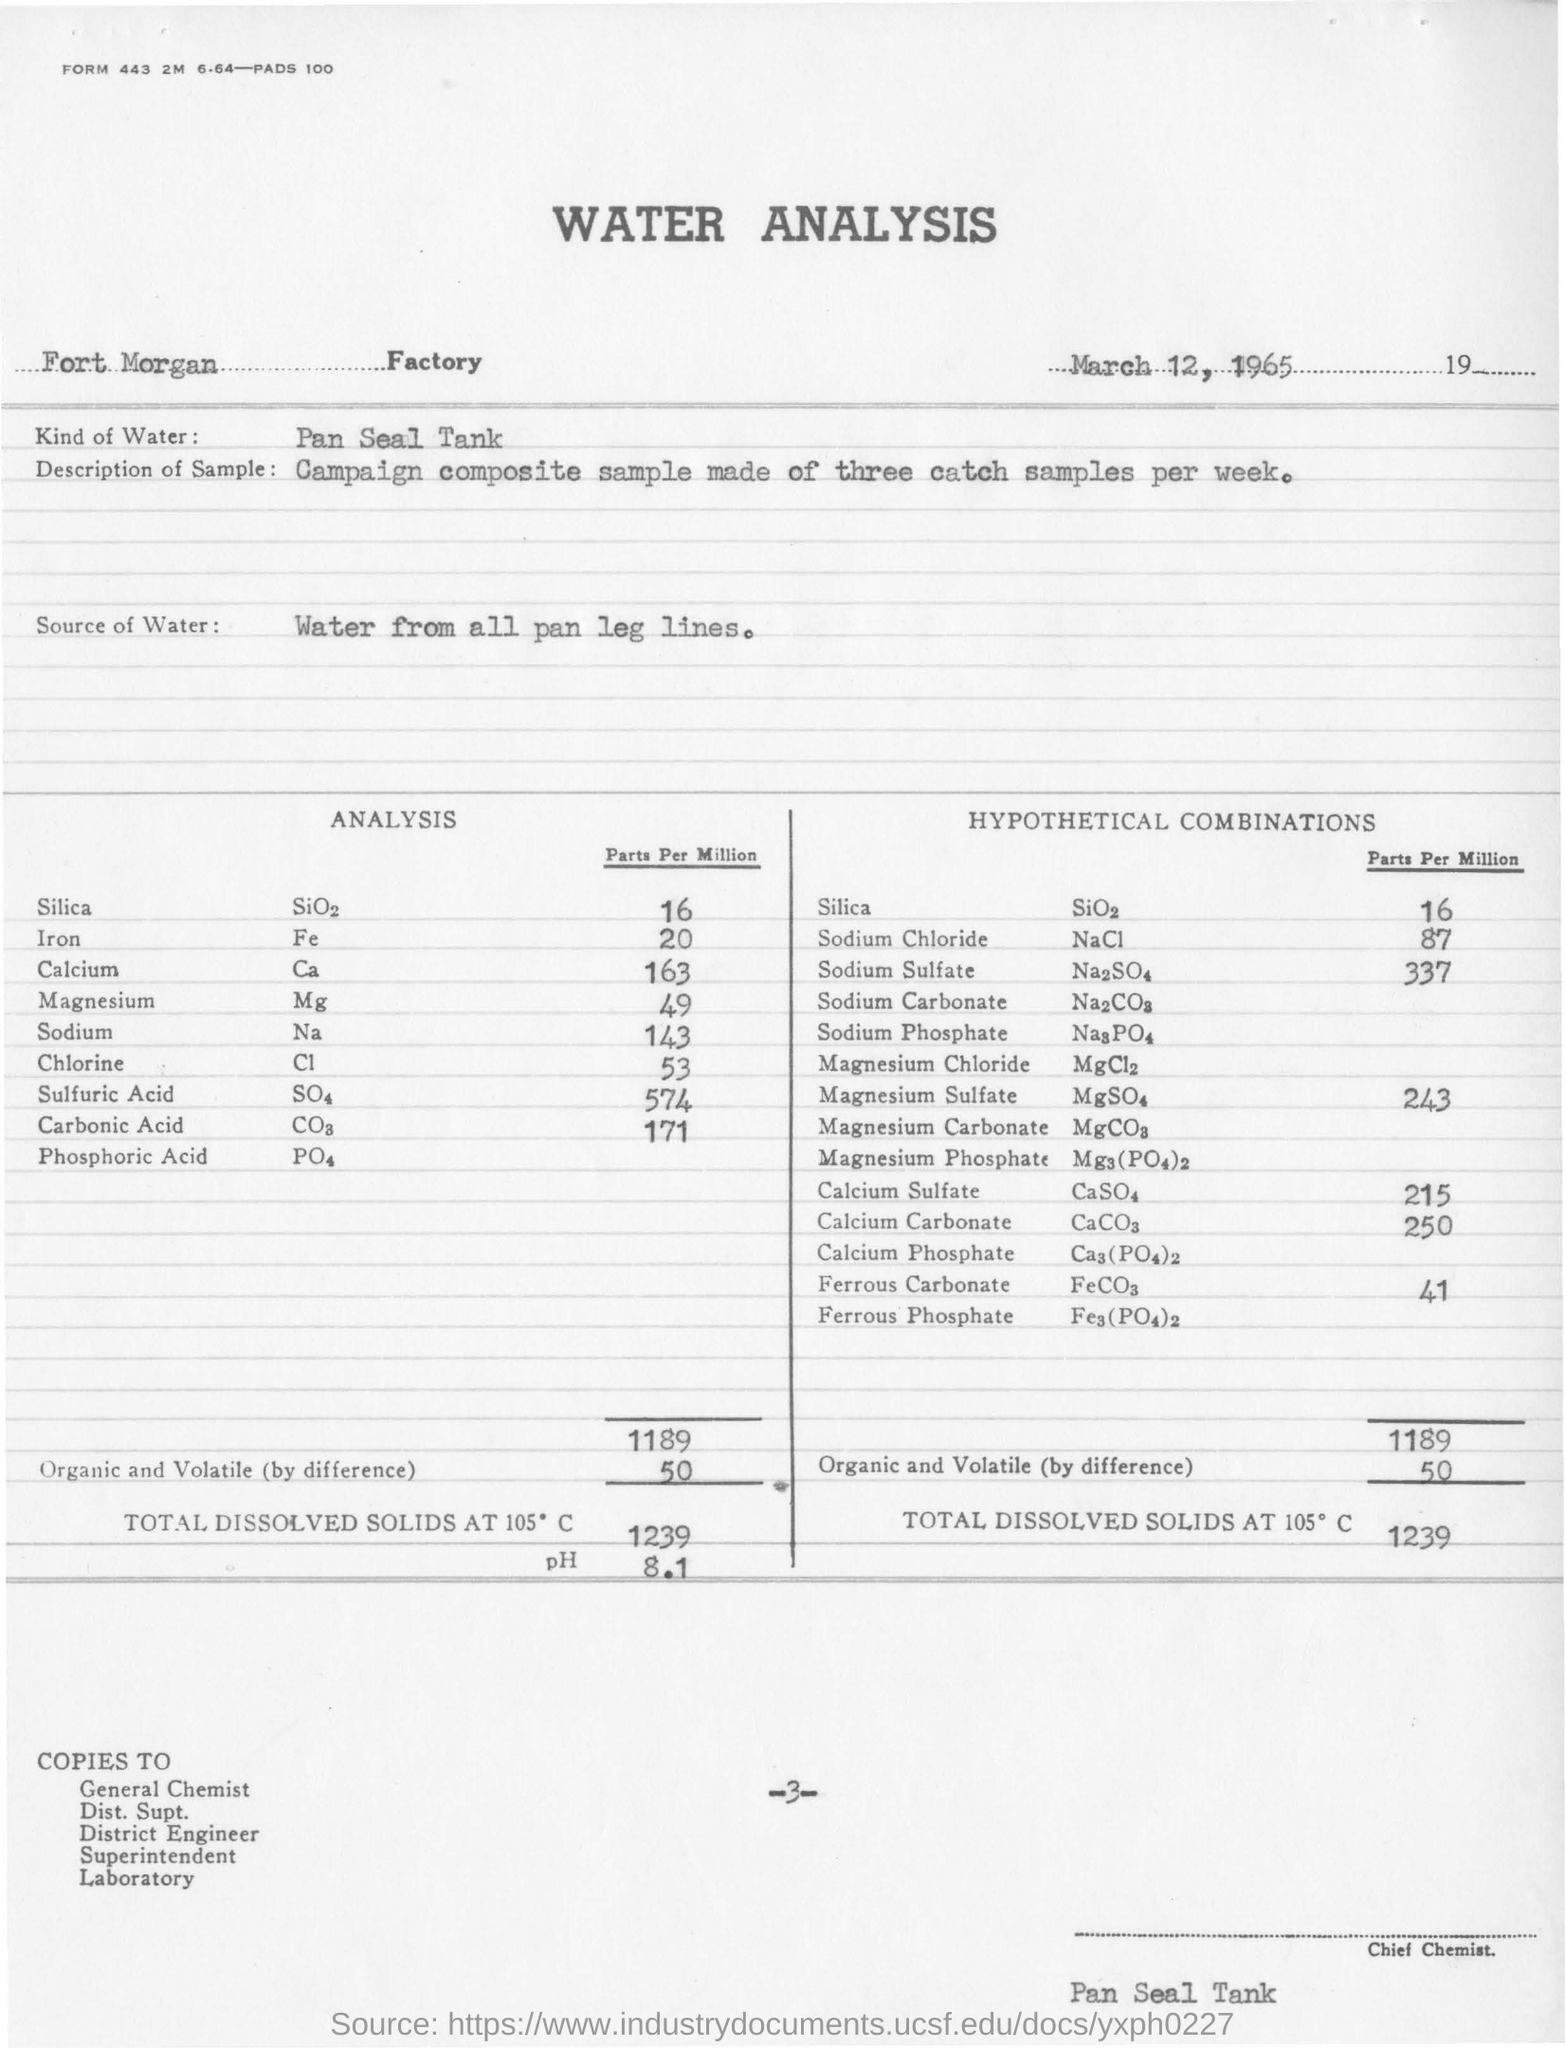When is the analysis dated?
Ensure brevity in your answer.  March 12, 1965. What is the name of the factory?
Ensure brevity in your answer.  Fort Morgan Factory. 